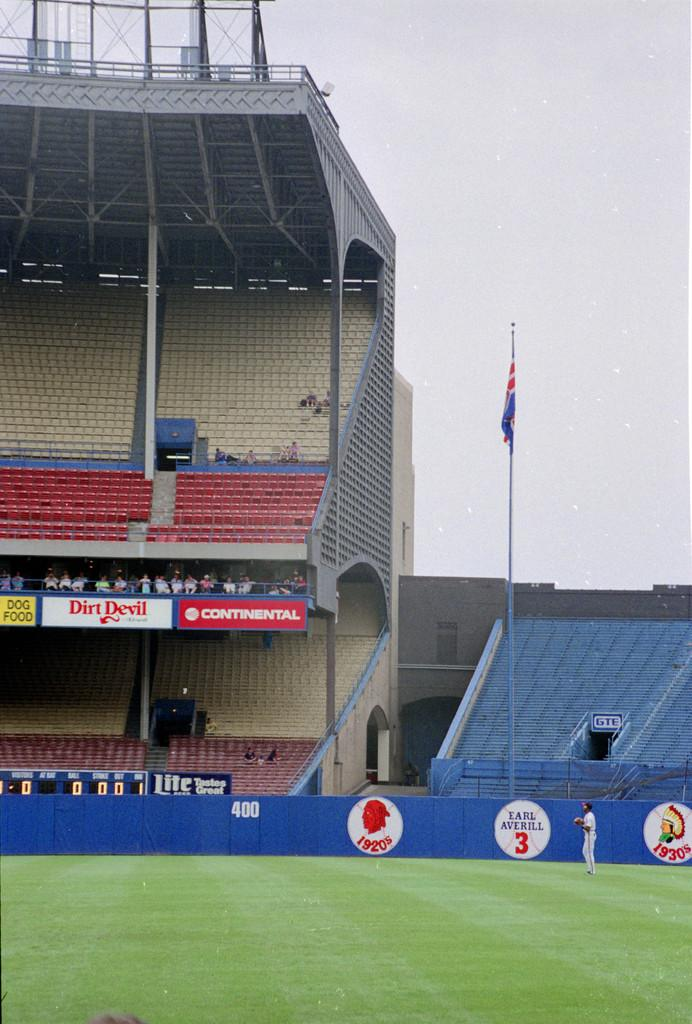<image>
Present a compact description of the photo's key features. A stadium displaying banners including one for Continental. 